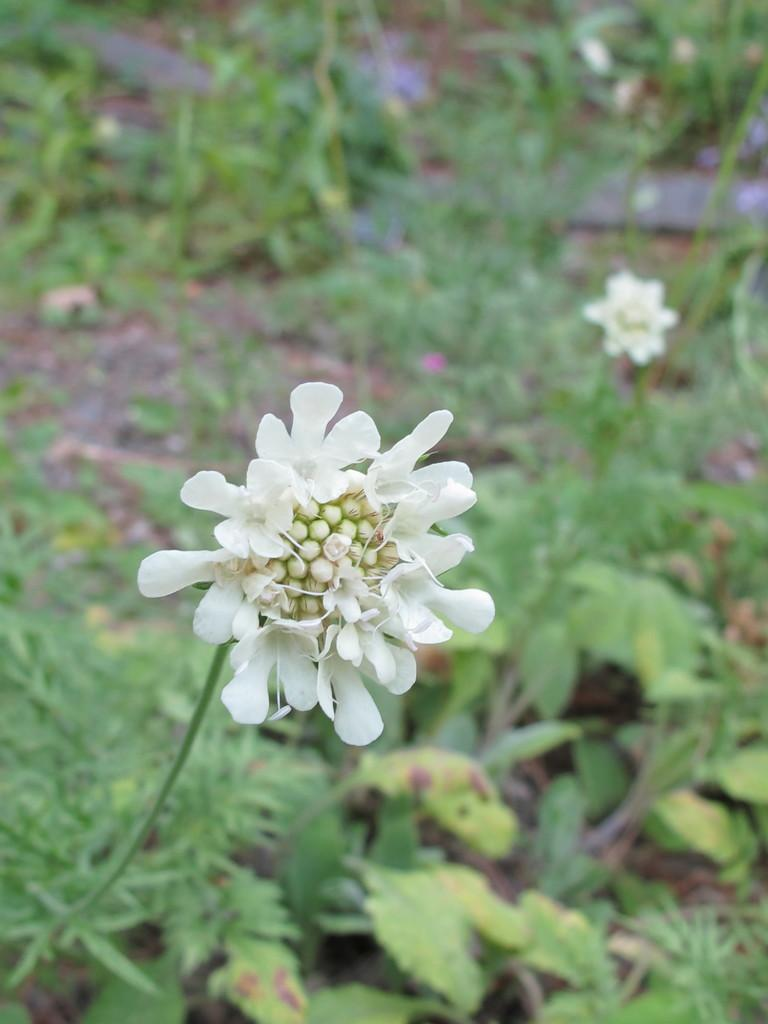What celestial bodies are visible in the image? There are planets visible in the image. What type of flora is present in the image? There are white color flowers in the image. What type of branch can be seen supporting the development of the babies in the image? There is no branch, babies, or development present in the image; it features planets and white color flowers. 